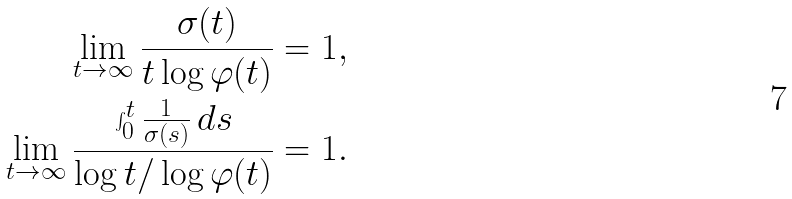<formula> <loc_0><loc_0><loc_500><loc_500>\lim _ { t \to \infty } \frac { \sigma ( t ) } { t \log \varphi ( t ) } = 1 , \\ \lim _ { t \to \infty } \frac { \int _ { 0 } ^ { t } \frac { 1 } { \sigma ( s ) } \, d s } { \log t / \log \varphi ( t ) } = 1 .</formula> 